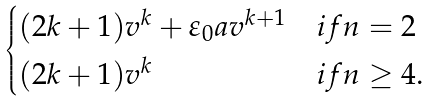Convert formula to latex. <formula><loc_0><loc_0><loc_500><loc_500>\begin{cases} ( 2 k + 1 ) v ^ { k } + \varepsilon _ { 0 } a v ^ { k + 1 } & i f n = 2 \\ ( 2 k + 1 ) v ^ { k } & i f n \geq 4 . \end{cases}</formula> 